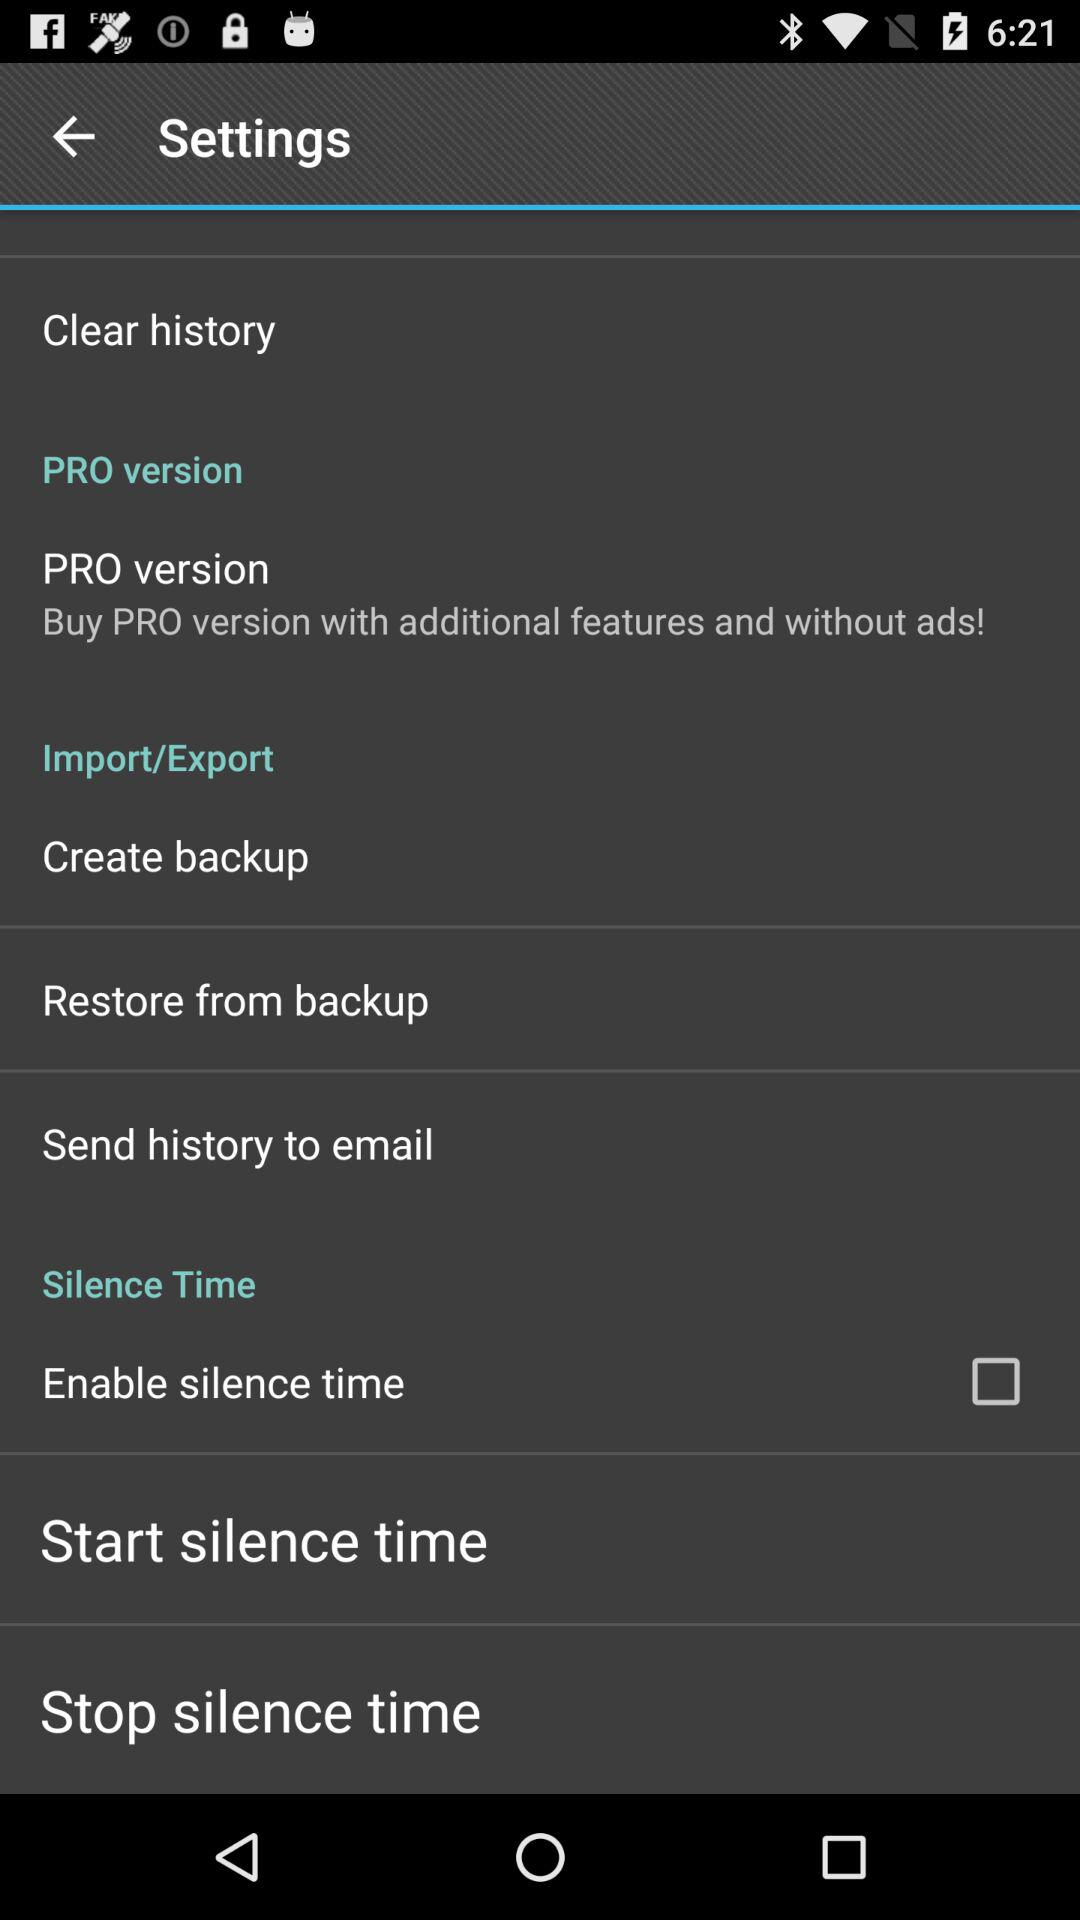What is the status of "Enable silence time"? The status is "off". 